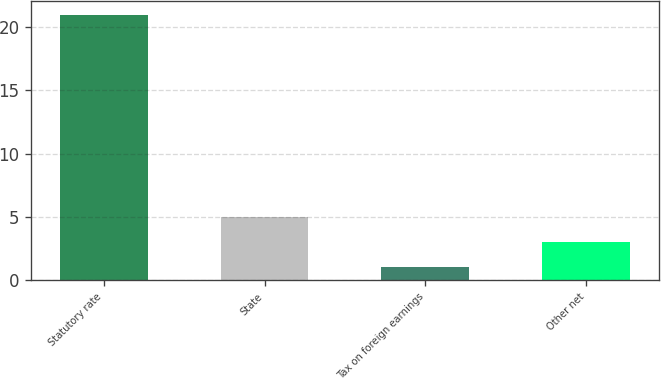Convert chart to OTSL. <chart><loc_0><loc_0><loc_500><loc_500><bar_chart><fcel>Statutory rate<fcel>State<fcel>Tax on foreign earnings<fcel>Other net<nl><fcel>21<fcel>5<fcel>1<fcel>3<nl></chart> 